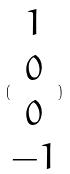<formula> <loc_0><loc_0><loc_500><loc_500>( \begin{matrix} 1 \\ 0 \\ 0 \\ - 1 \end{matrix} )</formula> 